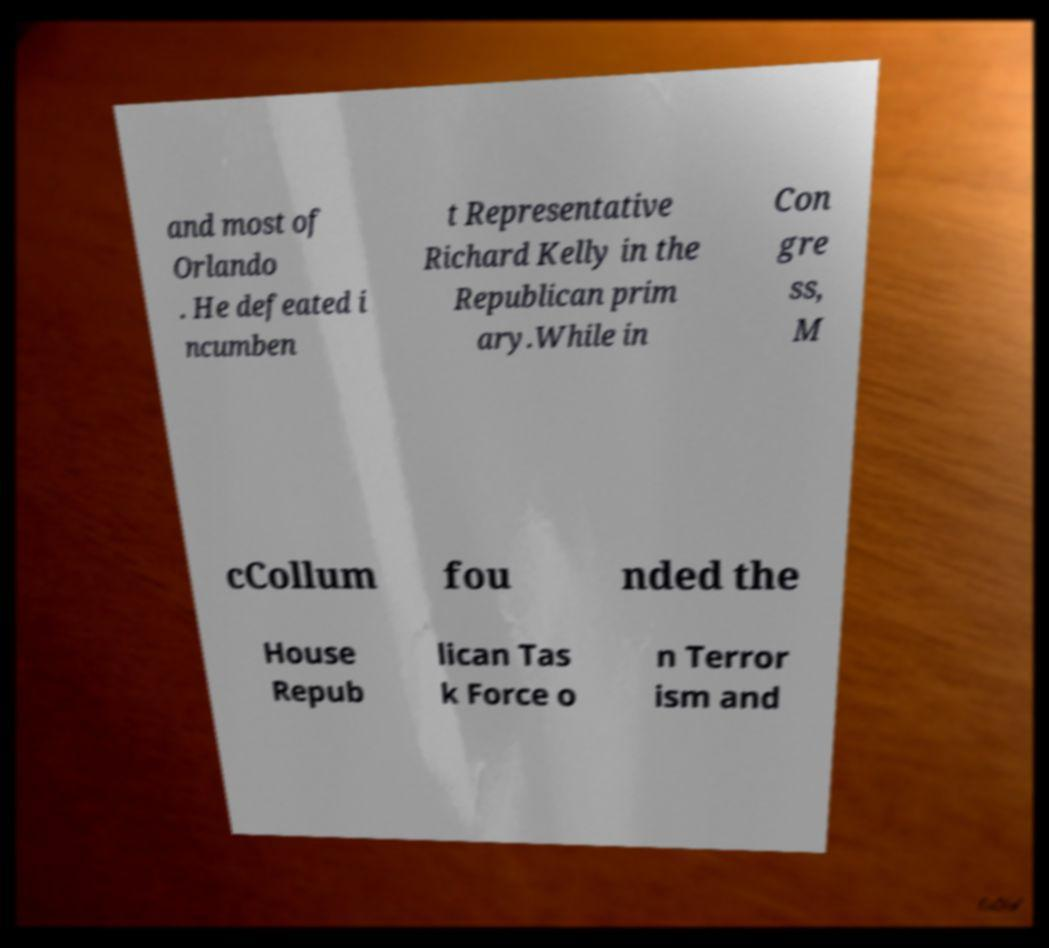Can you read and provide the text displayed in the image?This photo seems to have some interesting text. Can you extract and type it out for me? and most of Orlando . He defeated i ncumben t Representative Richard Kelly in the Republican prim ary.While in Con gre ss, M cCollum fou nded the House Repub lican Tas k Force o n Terror ism and 